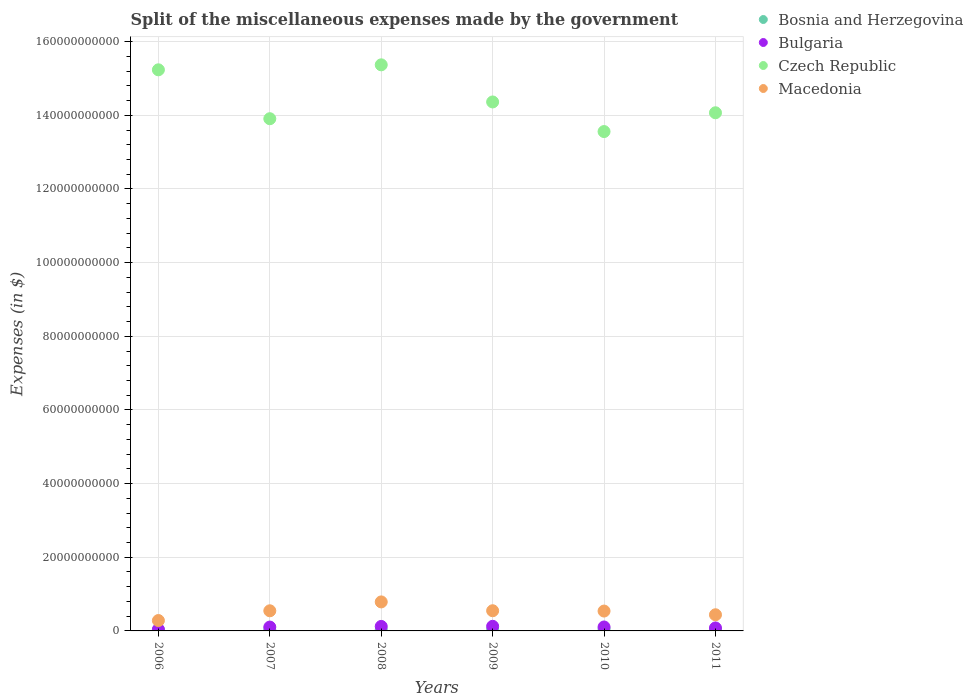How many different coloured dotlines are there?
Keep it short and to the point. 4. Is the number of dotlines equal to the number of legend labels?
Keep it short and to the point. Yes. What is the miscellaneous expenses made by the government in Bulgaria in 2011?
Your answer should be compact. 8.07e+08. Across all years, what is the maximum miscellaneous expenses made by the government in Bulgaria?
Your answer should be compact. 1.25e+09. Across all years, what is the minimum miscellaneous expenses made by the government in Bulgaria?
Make the answer very short. 4.12e+08. In which year was the miscellaneous expenses made by the government in Macedonia maximum?
Make the answer very short. 2008. What is the total miscellaneous expenses made by the government in Macedonia in the graph?
Your answer should be very brief. 3.14e+1. What is the difference between the miscellaneous expenses made by the government in Macedonia in 2008 and that in 2009?
Your answer should be very brief. 2.40e+09. What is the difference between the miscellaneous expenses made by the government in Bulgaria in 2006 and the miscellaneous expenses made by the government in Macedonia in 2008?
Your response must be concise. -7.47e+09. What is the average miscellaneous expenses made by the government in Czech Republic per year?
Provide a succinct answer. 1.44e+11. In the year 2006, what is the difference between the miscellaneous expenses made by the government in Bosnia and Herzegovina and miscellaneous expenses made by the government in Czech Republic?
Your answer should be compact. -1.52e+11. What is the ratio of the miscellaneous expenses made by the government in Bulgaria in 2006 to that in 2008?
Provide a succinct answer. 0.34. Is the difference between the miscellaneous expenses made by the government in Bosnia and Herzegovina in 2007 and 2011 greater than the difference between the miscellaneous expenses made by the government in Czech Republic in 2007 and 2011?
Ensure brevity in your answer.  Yes. What is the difference between the highest and the second highest miscellaneous expenses made by the government in Macedonia?
Make the answer very short. 2.40e+09. What is the difference between the highest and the lowest miscellaneous expenses made by the government in Bosnia and Herzegovina?
Your response must be concise. 2.61e+08. Is it the case that in every year, the sum of the miscellaneous expenses made by the government in Bosnia and Herzegovina and miscellaneous expenses made by the government in Bulgaria  is greater than the sum of miscellaneous expenses made by the government in Macedonia and miscellaneous expenses made by the government in Czech Republic?
Your answer should be compact. No. Is the miscellaneous expenses made by the government in Bosnia and Herzegovina strictly greater than the miscellaneous expenses made by the government in Czech Republic over the years?
Your answer should be compact. No. Is the miscellaneous expenses made by the government in Bulgaria strictly less than the miscellaneous expenses made by the government in Macedonia over the years?
Your response must be concise. Yes. How many dotlines are there?
Ensure brevity in your answer.  4. How many years are there in the graph?
Offer a very short reply. 6. What is the difference between two consecutive major ticks on the Y-axis?
Give a very brief answer. 2.00e+1. Are the values on the major ticks of Y-axis written in scientific E-notation?
Your answer should be very brief. No. Where does the legend appear in the graph?
Keep it short and to the point. Top right. How many legend labels are there?
Offer a terse response. 4. What is the title of the graph?
Offer a terse response. Split of the miscellaneous expenses made by the government. Does "Greece" appear as one of the legend labels in the graph?
Keep it short and to the point. No. What is the label or title of the Y-axis?
Give a very brief answer. Expenses (in $). What is the Expenses (in $) of Bosnia and Herzegovina in 2006?
Offer a terse response. 2.46e+08. What is the Expenses (in $) in Bulgaria in 2006?
Your response must be concise. 4.12e+08. What is the Expenses (in $) in Czech Republic in 2006?
Offer a very short reply. 1.52e+11. What is the Expenses (in $) in Macedonia in 2006?
Give a very brief answer. 2.82e+09. What is the Expenses (in $) in Bosnia and Herzegovina in 2007?
Ensure brevity in your answer.  3.01e+08. What is the Expenses (in $) of Bulgaria in 2007?
Ensure brevity in your answer.  1.05e+09. What is the Expenses (in $) in Czech Republic in 2007?
Make the answer very short. 1.39e+11. What is the Expenses (in $) of Macedonia in 2007?
Make the answer very short. 5.47e+09. What is the Expenses (in $) of Bosnia and Herzegovina in 2008?
Offer a very short reply. 3.19e+08. What is the Expenses (in $) in Bulgaria in 2008?
Your answer should be very brief. 1.22e+09. What is the Expenses (in $) of Czech Republic in 2008?
Make the answer very short. 1.54e+11. What is the Expenses (in $) of Macedonia in 2008?
Give a very brief answer. 7.88e+09. What is the Expenses (in $) in Bosnia and Herzegovina in 2009?
Your answer should be compact. 3.49e+08. What is the Expenses (in $) in Bulgaria in 2009?
Provide a succinct answer. 1.25e+09. What is the Expenses (in $) of Czech Republic in 2009?
Offer a terse response. 1.44e+11. What is the Expenses (in $) of Macedonia in 2009?
Your answer should be compact. 5.48e+09. What is the Expenses (in $) in Bosnia and Herzegovina in 2010?
Your answer should be very brief. 5.07e+08. What is the Expenses (in $) in Bulgaria in 2010?
Make the answer very short. 1.07e+09. What is the Expenses (in $) in Czech Republic in 2010?
Your response must be concise. 1.36e+11. What is the Expenses (in $) of Macedonia in 2010?
Keep it short and to the point. 5.39e+09. What is the Expenses (in $) in Bosnia and Herzegovina in 2011?
Keep it short and to the point. 3.88e+08. What is the Expenses (in $) in Bulgaria in 2011?
Offer a very short reply. 8.07e+08. What is the Expenses (in $) of Czech Republic in 2011?
Provide a succinct answer. 1.41e+11. What is the Expenses (in $) in Macedonia in 2011?
Give a very brief answer. 4.39e+09. Across all years, what is the maximum Expenses (in $) in Bosnia and Herzegovina?
Your response must be concise. 5.07e+08. Across all years, what is the maximum Expenses (in $) of Bulgaria?
Offer a very short reply. 1.25e+09. Across all years, what is the maximum Expenses (in $) in Czech Republic?
Keep it short and to the point. 1.54e+11. Across all years, what is the maximum Expenses (in $) of Macedonia?
Ensure brevity in your answer.  7.88e+09. Across all years, what is the minimum Expenses (in $) in Bosnia and Herzegovina?
Offer a terse response. 2.46e+08. Across all years, what is the minimum Expenses (in $) of Bulgaria?
Give a very brief answer. 4.12e+08. Across all years, what is the minimum Expenses (in $) in Czech Republic?
Give a very brief answer. 1.36e+11. Across all years, what is the minimum Expenses (in $) in Macedonia?
Ensure brevity in your answer.  2.82e+09. What is the total Expenses (in $) of Bosnia and Herzegovina in the graph?
Offer a very short reply. 2.11e+09. What is the total Expenses (in $) of Bulgaria in the graph?
Your response must be concise. 5.81e+09. What is the total Expenses (in $) in Czech Republic in the graph?
Give a very brief answer. 8.65e+11. What is the total Expenses (in $) of Macedonia in the graph?
Keep it short and to the point. 3.14e+1. What is the difference between the Expenses (in $) of Bosnia and Herzegovina in 2006 and that in 2007?
Ensure brevity in your answer.  -5.57e+07. What is the difference between the Expenses (in $) in Bulgaria in 2006 and that in 2007?
Ensure brevity in your answer.  -6.37e+08. What is the difference between the Expenses (in $) of Czech Republic in 2006 and that in 2007?
Your response must be concise. 1.33e+1. What is the difference between the Expenses (in $) of Macedonia in 2006 and that in 2007?
Your response must be concise. -2.65e+09. What is the difference between the Expenses (in $) in Bosnia and Herzegovina in 2006 and that in 2008?
Offer a terse response. -7.28e+07. What is the difference between the Expenses (in $) in Bulgaria in 2006 and that in 2008?
Provide a succinct answer. -8.09e+08. What is the difference between the Expenses (in $) in Czech Republic in 2006 and that in 2008?
Provide a short and direct response. -1.35e+09. What is the difference between the Expenses (in $) of Macedonia in 2006 and that in 2008?
Provide a succinct answer. -5.06e+09. What is the difference between the Expenses (in $) of Bosnia and Herzegovina in 2006 and that in 2009?
Make the answer very short. -1.03e+08. What is the difference between the Expenses (in $) of Bulgaria in 2006 and that in 2009?
Keep it short and to the point. -8.41e+08. What is the difference between the Expenses (in $) of Czech Republic in 2006 and that in 2009?
Give a very brief answer. 8.73e+09. What is the difference between the Expenses (in $) of Macedonia in 2006 and that in 2009?
Give a very brief answer. -2.66e+09. What is the difference between the Expenses (in $) in Bosnia and Herzegovina in 2006 and that in 2010?
Ensure brevity in your answer.  -2.61e+08. What is the difference between the Expenses (in $) of Bulgaria in 2006 and that in 2010?
Your response must be concise. -6.59e+08. What is the difference between the Expenses (in $) in Czech Republic in 2006 and that in 2010?
Offer a terse response. 1.68e+1. What is the difference between the Expenses (in $) of Macedonia in 2006 and that in 2010?
Provide a succinct answer. -2.57e+09. What is the difference between the Expenses (in $) in Bosnia and Herzegovina in 2006 and that in 2011?
Ensure brevity in your answer.  -1.42e+08. What is the difference between the Expenses (in $) of Bulgaria in 2006 and that in 2011?
Your answer should be very brief. -3.96e+08. What is the difference between the Expenses (in $) in Czech Republic in 2006 and that in 2011?
Ensure brevity in your answer.  1.17e+1. What is the difference between the Expenses (in $) in Macedonia in 2006 and that in 2011?
Give a very brief answer. -1.57e+09. What is the difference between the Expenses (in $) in Bosnia and Herzegovina in 2007 and that in 2008?
Your answer should be compact. -1.71e+07. What is the difference between the Expenses (in $) of Bulgaria in 2007 and that in 2008?
Keep it short and to the point. -1.72e+08. What is the difference between the Expenses (in $) in Czech Republic in 2007 and that in 2008?
Your answer should be compact. -1.46e+1. What is the difference between the Expenses (in $) of Macedonia in 2007 and that in 2008?
Your response must be concise. -2.41e+09. What is the difference between the Expenses (in $) of Bosnia and Herzegovina in 2007 and that in 2009?
Provide a short and direct response. -4.74e+07. What is the difference between the Expenses (in $) of Bulgaria in 2007 and that in 2009?
Give a very brief answer. -2.05e+08. What is the difference between the Expenses (in $) of Czech Republic in 2007 and that in 2009?
Keep it short and to the point. -4.55e+09. What is the difference between the Expenses (in $) of Macedonia in 2007 and that in 2009?
Ensure brevity in your answer.  -1.40e+07. What is the difference between the Expenses (in $) in Bosnia and Herzegovina in 2007 and that in 2010?
Offer a terse response. -2.06e+08. What is the difference between the Expenses (in $) in Bulgaria in 2007 and that in 2010?
Your answer should be compact. -2.27e+07. What is the difference between the Expenses (in $) in Czech Republic in 2007 and that in 2010?
Provide a short and direct response. 3.49e+09. What is the difference between the Expenses (in $) in Macedonia in 2007 and that in 2010?
Your answer should be compact. 7.30e+07. What is the difference between the Expenses (in $) in Bosnia and Herzegovina in 2007 and that in 2011?
Your answer should be very brief. -8.66e+07. What is the difference between the Expenses (in $) of Bulgaria in 2007 and that in 2011?
Your response must be concise. 2.41e+08. What is the difference between the Expenses (in $) of Czech Republic in 2007 and that in 2011?
Offer a very short reply. -1.61e+09. What is the difference between the Expenses (in $) in Macedonia in 2007 and that in 2011?
Offer a very short reply. 1.08e+09. What is the difference between the Expenses (in $) of Bosnia and Herzegovina in 2008 and that in 2009?
Keep it short and to the point. -3.03e+07. What is the difference between the Expenses (in $) in Bulgaria in 2008 and that in 2009?
Ensure brevity in your answer.  -3.22e+07. What is the difference between the Expenses (in $) of Czech Republic in 2008 and that in 2009?
Offer a very short reply. 1.01e+1. What is the difference between the Expenses (in $) in Macedonia in 2008 and that in 2009?
Provide a short and direct response. 2.40e+09. What is the difference between the Expenses (in $) in Bosnia and Herzegovina in 2008 and that in 2010?
Keep it short and to the point. -1.89e+08. What is the difference between the Expenses (in $) in Bulgaria in 2008 and that in 2010?
Your answer should be very brief. 1.50e+08. What is the difference between the Expenses (in $) of Czech Republic in 2008 and that in 2010?
Make the answer very short. 1.81e+1. What is the difference between the Expenses (in $) in Macedonia in 2008 and that in 2010?
Give a very brief answer. 2.48e+09. What is the difference between the Expenses (in $) of Bosnia and Herzegovina in 2008 and that in 2011?
Make the answer very short. -6.95e+07. What is the difference between the Expenses (in $) of Bulgaria in 2008 and that in 2011?
Your response must be concise. 4.13e+08. What is the difference between the Expenses (in $) in Czech Republic in 2008 and that in 2011?
Your response must be concise. 1.30e+1. What is the difference between the Expenses (in $) in Macedonia in 2008 and that in 2011?
Provide a succinct answer. 3.49e+09. What is the difference between the Expenses (in $) of Bosnia and Herzegovina in 2009 and that in 2010?
Offer a terse response. -1.58e+08. What is the difference between the Expenses (in $) in Bulgaria in 2009 and that in 2010?
Make the answer very short. 1.82e+08. What is the difference between the Expenses (in $) of Czech Republic in 2009 and that in 2010?
Give a very brief answer. 8.04e+09. What is the difference between the Expenses (in $) of Macedonia in 2009 and that in 2010?
Ensure brevity in your answer.  8.70e+07. What is the difference between the Expenses (in $) of Bosnia and Herzegovina in 2009 and that in 2011?
Provide a succinct answer. -3.92e+07. What is the difference between the Expenses (in $) of Bulgaria in 2009 and that in 2011?
Your answer should be compact. 4.46e+08. What is the difference between the Expenses (in $) in Czech Republic in 2009 and that in 2011?
Provide a short and direct response. 2.94e+09. What is the difference between the Expenses (in $) in Macedonia in 2009 and that in 2011?
Ensure brevity in your answer.  1.09e+09. What is the difference between the Expenses (in $) in Bosnia and Herzegovina in 2010 and that in 2011?
Give a very brief answer. 1.19e+08. What is the difference between the Expenses (in $) of Bulgaria in 2010 and that in 2011?
Make the answer very short. 2.64e+08. What is the difference between the Expenses (in $) of Czech Republic in 2010 and that in 2011?
Provide a short and direct response. -5.10e+09. What is the difference between the Expenses (in $) in Macedonia in 2010 and that in 2011?
Offer a terse response. 1.01e+09. What is the difference between the Expenses (in $) of Bosnia and Herzegovina in 2006 and the Expenses (in $) of Bulgaria in 2007?
Provide a short and direct response. -8.03e+08. What is the difference between the Expenses (in $) of Bosnia and Herzegovina in 2006 and the Expenses (in $) of Czech Republic in 2007?
Your response must be concise. -1.39e+11. What is the difference between the Expenses (in $) in Bosnia and Herzegovina in 2006 and the Expenses (in $) in Macedonia in 2007?
Keep it short and to the point. -5.22e+09. What is the difference between the Expenses (in $) of Bulgaria in 2006 and the Expenses (in $) of Czech Republic in 2007?
Give a very brief answer. -1.39e+11. What is the difference between the Expenses (in $) of Bulgaria in 2006 and the Expenses (in $) of Macedonia in 2007?
Offer a terse response. -5.05e+09. What is the difference between the Expenses (in $) of Czech Republic in 2006 and the Expenses (in $) of Macedonia in 2007?
Offer a very short reply. 1.47e+11. What is the difference between the Expenses (in $) in Bosnia and Herzegovina in 2006 and the Expenses (in $) in Bulgaria in 2008?
Give a very brief answer. -9.75e+08. What is the difference between the Expenses (in $) in Bosnia and Herzegovina in 2006 and the Expenses (in $) in Czech Republic in 2008?
Give a very brief answer. -1.53e+11. What is the difference between the Expenses (in $) in Bosnia and Herzegovina in 2006 and the Expenses (in $) in Macedonia in 2008?
Your response must be concise. -7.63e+09. What is the difference between the Expenses (in $) of Bulgaria in 2006 and the Expenses (in $) of Czech Republic in 2008?
Provide a succinct answer. -1.53e+11. What is the difference between the Expenses (in $) in Bulgaria in 2006 and the Expenses (in $) in Macedonia in 2008?
Keep it short and to the point. -7.47e+09. What is the difference between the Expenses (in $) of Czech Republic in 2006 and the Expenses (in $) of Macedonia in 2008?
Offer a terse response. 1.44e+11. What is the difference between the Expenses (in $) in Bosnia and Herzegovina in 2006 and the Expenses (in $) in Bulgaria in 2009?
Offer a very short reply. -1.01e+09. What is the difference between the Expenses (in $) of Bosnia and Herzegovina in 2006 and the Expenses (in $) of Czech Republic in 2009?
Your answer should be compact. -1.43e+11. What is the difference between the Expenses (in $) of Bosnia and Herzegovina in 2006 and the Expenses (in $) of Macedonia in 2009?
Give a very brief answer. -5.23e+09. What is the difference between the Expenses (in $) of Bulgaria in 2006 and the Expenses (in $) of Czech Republic in 2009?
Offer a terse response. -1.43e+11. What is the difference between the Expenses (in $) of Bulgaria in 2006 and the Expenses (in $) of Macedonia in 2009?
Provide a succinct answer. -5.07e+09. What is the difference between the Expenses (in $) in Czech Republic in 2006 and the Expenses (in $) in Macedonia in 2009?
Ensure brevity in your answer.  1.47e+11. What is the difference between the Expenses (in $) in Bosnia and Herzegovina in 2006 and the Expenses (in $) in Bulgaria in 2010?
Give a very brief answer. -8.25e+08. What is the difference between the Expenses (in $) in Bosnia and Herzegovina in 2006 and the Expenses (in $) in Czech Republic in 2010?
Your response must be concise. -1.35e+11. What is the difference between the Expenses (in $) in Bosnia and Herzegovina in 2006 and the Expenses (in $) in Macedonia in 2010?
Ensure brevity in your answer.  -5.15e+09. What is the difference between the Expenses (in $) of Bulgaria in 2006 and the Expenses (in $) of Czech Republic in 2010?
Your answer should be compact. -1.35e+11. What is the difference between the Expenses (in $) of Bulgaria in 2006 and the Expenses (in $) of Macedonia in 2010?
Provide a succinct answer. -4.98e+09. What is the difference between the Expenses (in $) in Czech Republic in 2006 and the Expenses (in $) in Macedonia in 2010?
Your answer should be very brief. 1.47e+11. What is the difference between the Expenses (in $) of Bosnia and Herzegovina in 2006 and the Expenses (in $) of Bulgaria in 2011?
Your response must be concise. -5.62e+08. What is the difference between the Expenses (in $) in Bosnia and Herzegovina in 2006 and the Expenses (in $) in Czech Republic in 2011?
Your answer should be compact. -1.40e+11. What is the difference between the Expenses (in $) in Bosnia and Herzegovina in 2006 and the Expenses (in $) in Macedonia in 2011?
Your response must be concise. -4.14e+09. What is the difference between the Expenses (in $) in Bulgaria in 2006 and the Expenses (in $) in Czech Republic in 2011?
Provide a short and direct response. -1.40e+11. What is the difference between the Expenses (in $) in Bulgaria in 2006 and the Expenses (in $) in Macedonia in 2011?
Offer a terse response. -3.98e+09. What is the difference between the Expenses (in $) of Czech Republic in 2006 and the Expenses (in $) of Macedonia in 2011?
Keep it short and to the point. 1.48e+11. What is the difference between the Expenses (in $) in Bosnia and Herzegovina in 2007 and the Expenses (in $) in Bulgaria in 2008?
Offer a very short reply. -9.19e+08. What is the difference between the Expenses (in $) in Bosnia and Herzegovina in 2007 and the Expenses (in $) in Czech Republic in 2008?
Offer a very short reply. -1.53e+11. What is the difference between the Expenses (in $) of Bosnia and Herzegovina in 2007 and the Expenses (in $) of Macedonia in 2008?
Provide a succinct answer. -7.58e+09. What is the difference between the Expenses (in $) of Bulgaria in 2007 and the Expenses (in $) of Czech Republic in 2008?
Give a very brief answer. -1.53e+11. What is the difference between the Expenses (in $) in Bulgaria in 2007 and the Expenses (in $) in Macedonia in 2008?
Provide a succinct answer. -6.83e+09. What is the difference between the Expenses (in $) in Czech Republic in 2007 and the Expenses (in $) in Macedonia in 2008?
Your answer should be very brief. 1.31e+11. What is the difference between the Expenses (in $) in Bosnia and Herzegovina in 2007 and the Expenses (in $) in Bulgaria in 2009?
Your answer should be compact. -9.52e+08. What is the difference between the Expenses (in $) in Bosnia and Herzegovina in 2007 and the Expenses (in $) in Czech Republic in 2009?
Your response must be concise. -1.43e+11. What is the difference between the Expenses (in $) in Bosnia and Herzegovina in 2007 and the Expenses (in $) in Macedonia in 2009?
Make the answer very short. -5.18e+09. What is the difference between the Expenses (in $) in Bulgaria in 2007 and the Expenses (in $) in Czech Republic in 2009?
Make the answer very short. -1.43e+11. What is the difference between the Expenses (in $) in Bulgaria in 2007 and the Expenses (in $) in Macedonia in 2009?
Offer a terse response. -4.43e+09. What is the difference between the Expenses (in $) of Czech Republic in 2007 and the Expenses (in $) of Macedonia in 2009?
Your response must be concise. 1.34e+11. What is the difference between the Expenses (in $) in Bosnia and Herzegovina in 2007 and the Expenses (in $) in Bulgaria in 2010?
Ensure brevity in your answer.  -7.70e+08. What is the difference between the Expenses (in $) of Bosnia and Herzegovina in 2007 and the Expenses (in $) of Czech Republic in 2010?
Provide a short and direct response. -1.35e+11. What is the difference between the Expenses (in $) in Bosnia and Herzegovina in 2007 and the Expenses (in $) in Macedonia in 2010?
Your answer should be very brief. -5.09e+09. What is the difference between the Expenses (in $) in Bulgaria in 2007 and the Expenses (in $) in Czech Republic in 2010?
Provide a succinct answer. -1.35e+11. What is the difference between the Expenses (in $) in Bulgaria in 2007 and the Expenses (in $) in Macedonia in 2010?
Ensure brevity in your answer.  -4.34e+09. What is the difference between the Expenses (in $) in Czech Republic in 2007 and the Expenses (in $) in Macedonia in 2010?
Your answer should be very brief. 1.34e+11. What is the difference between the Expenses (in $) in Bosnia and Herzegovina in 2007 and the Expenses (in $) in Bulgaria in 2011?
Offer a terse response. -5.06e+08. What is the difference between the Expenses (in $) in Bosnia and Herzegovina in 2007 and the Expenses (in $) in Czech Republic in 2011?
Your response must be concise. -1.40e+11. What is the difference between the Expenses (in $) in Bosnia and Herzegovina in 2007 and the Expenses (in $) in Macedonia in 2011?
Ensure brevity in your answer.  -4.09e+09. What is the difference between the Expenses (in $) of Bulgaria in 2007 and the Expenses (in $) of Czech Republic in 2011?
Provide a short and direct response. -1.40e+11. What is the difference between the Expenses (in $) of Bulgaria in 2007 and the Expenses (in $) of Macedonia in 2011?
Your response must be concise. -3.34e+09. What is the difference between the Expenses (in $) of Czech Republic in 2007 and the Expenses (in $) of Macedonia in 2011?
Provide a short and direct response. 1.35e+11. What is the difference between the Expenses (in $) in Bosnia and Herzegovina in 2008 and the Expenses (in $) in Bulgaria in 2009?
Provide a short and direct response. -9.34e+08. What is the difference between the Expenses (in $) in Bosnia and Herzegovina in 2008 and the Expenses (in $) in Czech Republic in 2009?
Your response must be concise. -1.43e+11. What is the difference between the Expenses (in $) in Bosnia and Herzegovina in 2008 and the Expenses (in $) in Macedonia in 2009?
Provide a succinct answer. -5.16e+09. What is the difference between the Expenses (in $) of Bulgaria in 2008 and the Expenses (in $) of Czech Republic in 2009?
Provide a succinct answer. -1.42e+11. What is the difference between the Expenses (in $) of Bulgaria in 2008 and the Expenses (in $) of Macedonia in 2009?
Your answer should be compact. -4.26e+09. What is the difference between the Expenses (in $) in Czech Republic in 2008 and the Expenses (in $) in Macedonia in 2009?
Your response must be concise. 1.48e+11. What is the difference between the Expenses (in $) in Bosnia and Herzegovina in 2008 and the Expenses (in $) in Bulgaria in 2010?
Ensure brevity in your answer.  -7.53e+08. What is the difference between the Expenses (in $) in Bosnia and Herzegovina in 2008 and the Expenses (in $) in Czech Republic in 2010?
Offer a very short reply. -1.35e+11. What is the difference between the Expenses (in $) of Bosnia and Herzegovina in 2008 and the Expenses (in $) of Macedonia in 2010?
Make the answer very short. -5.07e+09. What is the difference between the Expenses (in $) in Bulgaria in 2008 and the Expenses (in $) in Czech Republic in 2010?
Provide a short and direct response. -1.34e+11. What is the difference between the Expenses (in $) in Bulgaria in 2008 and the Expenses (in $) in Macedonia in 2010?
Ensure brevity in your answer.  -4.17e+09. What is the difference between the Expenses (in $) in Czech Republic in 2008 and the Expenses (in $) in Macedonia in 2010?
Your answer should be very brief. 1.48e+11. What is the difference between the Expenses (in $) of Bosnia and Herzegovina in 2008 and the Expenses (in $) of Bulgaria in 2011?
Provide a short and direct response. -4.89e+08. What is the difference between the Expenses (in $) of Bosnia and Herzegovina in 2008 and the Expenses (in $) of Czech Republic in 2011?
Offer a very short reply. -1.40e+11. What is the difference between the Expenses (in $) of Bosnia and Herzegovina in 2008 and the Expenses (in $) of Macedonia in 2011?
Provide a succinct answer. -4.07e+09. What is the difference between the Expenses (in $) of Bulgaria in 2008 and the Expenses (in $) of Czech Republic in 2011?
Your answer should be compact. -1.39e+11. What is the difference between the Expenses (in $) of Bulgaria in 2008 and the Expenses (in $) of Macedonia in 2011?
Your answer should be very brief. -3.17e+09. What is the difference between the Expenses (in $) in Czech Republic in 2008 and the Expenses (in $) in Macedonia in 2011?
Your answer should be compact. 1.49e+11. What is the difference between the Expenses (in $) in Bosnia and Herzegovina in 2009 and the Expenses (in $) in Bulgaria in 2010?
Ensure brevity in your answer.  -7.22e+08. What is the difference between the Expenses (in $) in Bosnia and Herzegovina in 2009 and the Expenses (in $) in Czech Republic in 2010?
Your answer should be compact. -1.35e+11. What is the difference between the Expenses (in $) in Bosnia and Herzegovina in 2009 and the Expenses (in $) in Macedonia in 2010?
Keep it short and to the point. -5.04e+09. What is the difference between the Expenses (in $) in Bulgaria in 2009 and the Expenses (in $) in Czech Republic in 2010?
Make the answer very short. -1.34e+11. What is the difference between the Expenses (in $) in Bulgaria in 2009 and the Expenses (in $) in Macedonia in 2010?
Offer a very short reply. -4.14e+09. What is the difference between the Expenses (in $) of Czech Republic in 2009 and the Expenses (in $) of Macedonia in 2010?
Give a very brief answer. 1.38e+11. What is the difference between the Expenses (in $) in Bosnia and Herzegovina in 2009 and the Expenses (in $) in Bulgaria in 2011?
Your response must be concise. -4.59e+08. What is the difference between the Expenses (in $) of Bosnia and Herzegovina in 2009 and the Expenses (in $) of Czech Republic in 2011?
Give a very brief answer. -1.40e+11. What is the difference between the Expenses (in $) of Bosnia and Herzegovina in 2009 and the Expenses (in $) of Macedonia in 2011?
Offer a terse response. -4.04e+09. What is the difference between the Expenses (in $) of Bulgaria in 2009 and the Expenses (in $) of Czech Republic in 2011?
Ensure brevity in your answer.  -1.39e+11. What is the difference between the Expenses (in $) of Bulgaria in 2009 and the Expenses (in $) of Macedonia in 2011?
Give a very brief answer. -3.13e+09. What is the difference between the Expenses (in $) in Czech Republic in 2009 and the Expenses (in $) in Macedonia in 2011?
Your answer should be compact. 1.39e+11. What is the difference between the Expenses (in $) in Bosnia and Herzegovina in 2010 and the Expenses (in $) in Bulgaria in 2011?
Your answer should be compact. -3.00e+08. What is the difference between the Expenses (in $) of Bosnia and Herzegovina in 2010 and the Expenses (in $) of Czech Republic in 2011?
Keep it short and to the point. -1.40e+11. What is the difference between the Expenses (in $) of Bosnia and Herzegovina in 2010 and the Expenses (in $) of Macedonia in 2011?
Offer a very short reply. -3.88e+09. What is the difference between the Expenses (in $) of Bulgaria in 2010 and the Expenses (in $) of Czech Republic in 2011?
Your response must be concise. -1.40e+11. What is the difference between the Expenses (in $) in Bulgaria in 2010 and the Expenses (in $) in Macedonia in 2011?
Provide a short and direct response. -3.32e+09. What is the difference between the Expenses (in $) of Czech Republic in 2010 and the Expenses (in $) of Macedonia in 2011?
Ensure brevity in your answer.  1.31e+11. What is the average Expenses (in $) in Bosnia and Herzegovina per year?
Keep it short and to the point. 3.52e+08. What is the average Expenses (in $) of Bulgaria per year?
Provide a succinct answer. 9.69e+08. What is the average Expenses (in $) of Czech Republic per year?
Keep it short and to the point. 1.44e+11. What is the average Expenses (in $) of Macedonia per year?
Provide a short and direct response. 5.24e+09. In the year 2006, what is the difference between the Expenses (in $) of Bosnia and Herzegovina and Expenses (in $) of Bulgaria?
Your answer should be very brief. -1.66e+08. In the year 2006, what is the difference between the Expenses (in $) in Bosnia and Herzegovina and Expenses (in $) in Czech Republic?
Your answer should be very brief. -1.52e+11. In the year 2006, what is the difference between the Expenses (in $) in Bosnia and Herzegovina and Expenses (in $) in Macedonia?
Your response must be concise. -2.57e+09. In the year 2006, what is the difference between the Expenses (in $) of Bulgaria and Expenses (in $) of Czech Republic?
Your response must be concise. -1.52e+11. In the year 2006, what is the difference between the Expenses (in $) of Bulgaria and Expenses (in $) of Macedonia?
Make the answer very short. -2.41e+09. In the year 2006, what is the difference between the Expenses (in $) in Czech Republic and Expenses (in $) in Macedonia?
Your answer should be very brief. 1.50e+11. In the year 2007, what is the difference between the Expenses (in $) of Bosnia and Herzegovina and Expenses (in $) of Bulgaria?
Ensure brevity in your answer.  -7.47e+08. In the year 2007, what is the difference between the Expenses (in $) of Bosnia and Herzegovina and Expenses (in $) of Czech Republic?
Your response must be concise. -1.39e+11. In the year 2007, what is the difference between the Expenses (in $) of Bosnia and Herzegovina and Expenses (in $) of Macedonia?
Your response must be concise. -5.16e+09. In the year 2007, what is the difference between the Expenses (in $) in Bulgaria and Expenses (in $) in Czech Republic?
Keep it short and to the point. -1.38e+11. In the year 2007, what is the difference between the Expenses (in $) in Bulgaria and Expenses (in $) in Macedonia?
Your answer should be very brief. -4.42e+09. In the year 2007, what is the difference between the Expenses (in $) in Czech Republic and Expenses (in $) in Macedonia?
Make the answer very short. 1.34e+11. In the year 2008, what is the difference between the Expenses (in $) of Bosnia and Herzegovina and Expenses (in $) of Bulgaria?
Provide a short and direct response. -9.02e+08. In the year 2008, what is the difference between the Expenses (in $) in Bosnia and Herzegovina and Expenses (in $) in Czech Republic?
Make the answer very short. -1.53e+11. In the year 2008, what is the difference between the Expenses (in $) of Bosnia and Herzegovina and Expenses (in $) of Macedonia?
Your answer should be very brief. -7.56e+09. In the year 2008, what is the difference between the Expenses (in $) of Bulgaria and Expenses (in $) of Czech Republic?
Your answer should be very brief. -1.52e+11. In the year 2008, what is the difference between the Expenses (in $) in Bulgaria and Expenses (in $) in Macedonia?
Your answer should be very brief. -6.66e+09. In the year 2008, what is the difference between the Expenses (in $) of Czech Republic and Expenses (in $) of Macedonia?
Offer a terse response. 1.46e+11. In the year 2009, what is the difference between the Expenses (in $) of Bosnia and Herzegovina and Expenses (in $) of Bulgaria?
Your answer should be compact. -9.04e+08. In the year 2009, what is the difference between the Expenses (in $) of Bosnia and Herzegovina and Expenses (in $) of Czech Republic?
Your response must be concise. -1.43e+11. In the year 2009, what is the difference between the Expenses (in $) in Bosnia and Herzegovina and Expenses (in $) in Macedonia?
Your response must be concise. -5.13e+09. In the year 2009, what is the difference between the Expenses (in $) of Bulgaria and Expenses (in $) of Czech Republic?
Ensure brevity in your answer.  -1.42e+11. In the year 2009, what is the difference between the Expenses (in $) in Bulgaria and Expenses (in $) in Macedonia?
Make the answer very short. -4.23e+09. In the year 2009, what is the difference between the Expenses (in $) of Czech Republic and Expenses (in $) of Macedonia?
Offer a very short reply. 1.38e+11. In the year 2010, what is the difference between the Expenses (in $) of Bosnia and Herzegovina and Expenses (in $) of Bulgaria?
Offer a very short reply. -5.64e+08. In the year 2010, what is the difference between the Expenses (in $) in Bosnia and Herzegovina and Expenses (in $) in Czech Republic?
Give a very brief answer. -1.35e+11. In the year 2010, what is the difference between the Expenses (in $) in Bosnia and Herzegovina and Expenses (in $) in Macedonia?
Provide a short and direct response. -4.89e+09. In the year 2010, what is the difference between the Expenses (in $) in Bulgaria and Expenses (in $) in Czech Republic?
Your response must be concise. -1.35e+11. In the year 2010, what is the difference between the Expenses (in $) in Bulgaria and Expenses (in $) in Macedonia?
Your answer should be compact. -4.32e+09. In the year 2010, what is the difference between the Expenses (in $) in Czech Republic and Expenses (in $) in Macedonia?
Offer a terse response. 1.30e+11. In the year 2011, what is the difference between the Expenses (in $) in Bosnia and Herzegovina and Expenses (in $) in Bulgaria?
Make the answer very short. -4.19e+08. In the year 2011, what is the difference between the Expenses (in $) of Bosnia and Herzegovina and Expenses (in $) of Czech Republic?
Your answer should be very brief. -1.40e+11. In the year 2011, what is the difference between the Expenses (in $) in Bosnia and Herzegovina and Expenses (in $) in Macedonia?
Provide a short and direct response. -4.00e+09. In the year 2011, what is the difference between the Expenses (in $) of Bulgaria and Expenses (in $) of Czech Republic?
Your answer should be very brief. -1.40e+11. In the year 2011, what is the difference between the Expenses (in $) of Bulgaria and Expenses (in $) of Macedonia?
Your answer should be very brief. -3.58e+09. In the year 2011, what is the difference between the Expenses (in $) in Czech Republic and Expenses (in $) in Macedonia?
Your answer should be very brief. 1.36e+11. What is the ratio of the Expenses (in $) in Bosnia and Herzegovina in 2006 to that in 2007?
Offer a very short reply. 0.82. What is the ratio of the Expenses (in $) of Bulgaria in 2006 to that in 2007?
Keep it short and to the point. 0.39. What is the ratio of the Expenses (in $) in Czech Republic in 2006 to that in 2007?
Give a very brief answer. 1.1. What is the ratio of the Expenses (in $) in Macedonia in 2006 to that in 2007?
Your answer should be compact. 0.52. What is the ratio of the Expenses (in $) in Bosnia and Herzegovina in 2006 to that in 2008?
Provide a short and direct response. 0.77. What is the ratio of the Expenses (in $) of Bulgaria in 2006 to that in 2008?
Your answer should be very brief. 0.34. What is the ratio of the Expenses (in $) in Macedonia in 2006 to that in 2008?
Provide a succinct answer. 0.36. What is the ratio of the Expenses (in $) of Bosnia and Herzegovina in 2006 to that in 2009?
Provide a succinct answer. 0.7. What is the ratio of the Expenses (in $) of Bulgaria in 2006 to that in 2009?
Your answer should be very brief. 0.33. What is the ratio of the Expenses (in $) in Czech Republic in 2006 to that in 2009?
Provide a short and direct response. 1.06. What is the ratio of the Expenses (in $) in Macedonia in 2006 to that in 2009?
Provide a succinct answer. 0.51. What is the ratio of the Expenses (in $) in Bosnia and Herzegovina in 2006 to that in 2010?
Offer a very short reply. 0.48. What is the ratio of the Expenses (in $) in Bulgaria in 2006 to that in 2010?
Offer a very short reply. 0.38. What is the ratio of the Expenses (in $) of Czech Republic in 2006 to that in 2010?
Your answer should be very brief. 1.12. What is the ratio of the Expenses (in $) in Macedonia in 2006 to that in 2010?
Give a very brief answer. 0.52. What is the ratio of the Expenses (in $) in Bosnia and Herzegovina in 2006 to that in 2011?
Provide a succinct answer. 0.63. What is the ratio of the Expenses (in $) of Bulgaria in 2006 to that in 2011?
Provide a succinct answer. 0.51. What is the ratio of the Expenses (in $) in Czech Republic in 2006 to that in 2011?
Give a very brief answer. 1.08. What is the ratio of the Expenses (in $) in Macedonia in 2006 to that in 2011?
Give a very brief answer. 0.64. What is the ratio of the Expenses (in $) in Bosnia and Herzegovina in 2007 to that in 2008?
Give a very brief answer. 0.95. What is the ratio of the Expenses (in $) of Bulgaria in 2007 to that in 2008?
Your answer should be very brief. 0.86. What is the ratio of the Expenses (in $) in Czech Republic in 2007 to that in 2008?
Offer a very short reply. 0.9. What is the ratio of the Expenses (in $) of Macedonia in 2007 to that in 2008?
Make the answer very short. 0.69. What is the ratio of the Expenses (in $) in Bosnia and Herzegovina in 2007 to that in 2009?
Make the answer very short. 0.86. What is the ratio of the Expenses (in $) of Bulgaria in 2007 to that in 2009?
Your answer should be compact. 0.84. What is the ratio of the Expenses (in $) in Czech Republic in 2007 to that in 2009?
Offer a very short reply. 0.97. What is the ratio of the Expenses (in $) in Macedonia in 2007 to that in 2009?
Offer a terse response. 1. What is the ratio of the Expenses (in $) of Bosnia and Herzegovina in 2007 to that in 2010?
Provide a succinct answer. 0.59. What is the ratio of the Expenses (in $) in Bulgaria in 2007 to that in 2010?
Offer a terse response. 0.98. What is the ratio of the Expenses (in $) of Czech Republic in 2007 to that in 2010?
Offer a terse response. 1.03. What is the ratio of the Expenses (in $) in Macedonia in 2007 to that in 2010?
Provide a succinct answer. 1.01. What is the ratio of the Expenses (in $) of Bosnia and Herzegovina in 2007 to that in 2011?
Make the answer very short. 0.78. What is the ratio of the Expenses (in $) of Bulgaria in 2007 to that in 2011?
Provide a succinct answer. 1.3. What is the ratio of the Expenses (in $) in Czech Republic in 2007 to that in 2011?
Provide a short and direct response. 0.99. What is the ratio of the Expenses (in $) of Macedonia in 2007 to that in 2011?
Give a very brief answer. 1.25. What is the ratio of the Expenses (in $) in Bosnia and Herzegovina in 2008 to that in 2009?
Your answer should be compact. 0.91. What is the ratio of the Expenses (in $) of Bulgaria in 2008 to that in 2009?
Your answer should be very brief. 0.97. What is the ratio of the Expenses (in $) of Czech Republic in 2008 to that in 2009?
Provide a short and direct response. 1.07. What is the ratio of the Expenses (in $) of Macedonia in 2008 to that in 2009?
Ensure brevity in your answer.  1.44. What is the ratio of the Expenses (in $) of Bosnia and Herzegovina in 2008 to that in 2010?
Your answer should be compact. 0.63. What is the ratio of the Expenses (in $) of Bulgaria in 2008 to that in 2010?
Provide a succinct answer. 1.14. What is the ratio of the Expenses (in $) of Czech Republic in 2008 to that in 2010?
Offer a very short reply. 1.13. What is the ratio of the Expenses (in $) in Macedonia in 2008 to that in 2010?
Your answer should be very brief. 1.46. What is the ratio of the Expenses (in $) in Bosnia and Herzegovina in 2008 to that in 2011?
Offer a terse response. 0.82. What is the ratio of the Expenses (in $) in Bulgaria in 2008 to that in 2011?
Offer a terse response. 1.51. What is the ratio of the Expenses (in $) of Czech Republic in 2008 to that in 2011?
Your answer should be very brief. 1.09. What is the ratio of the Expenses (in $) of Macedonia in 2008 to that in 2011?
Provide a short and direct response. 1.8. What is the ratio of the Expenses (in $) in Bosnia and Herzegovina in 2009 to that in 2010?
Provide a succinct answer. 0.69. What is the ratio of the Expenses (in $) in Bulgaria in 2009 to that in 2010?
Give a very brief answer. 1.17. What is the ratio of the Expenses (in $) of Czech Republic in 2009 to that in 2010?
Your answer should be very brief. 1.06. What is the ratio of the Expenses (in $) in Macedonia in 2009 to that in 2010?
Keep it short and to the point. 1.02. What is the ratio of the Expenses (in $) in Bosnia and Herzegovina in 2009 to that in 2011?
Provide a short and direct response. 0.9. What is the ratio of the Expenses (in $) in Bulgaria in 2009 to that in 2011?
Your response must be concise. 1.55. What is the ratio of the Expenses (in $) of Czech Republic in 2009 to that in 2011?
Make the answer very short. 1.02. What is the ratio of the Expenses (in $) of Macedonia in 2009 to that in 2011?
Ensure brevity in your answer.  1.25. What is the ratio of the Expenses (in $) of Bosnia and Herzegovina in 2010 to that in 2011?
Your answer should be very brief. 1.31. What is the ratio of the Expenses (in $) of Bulgaria in 2010 to that in 2011?
Offer a terse response. 1.33. What is the ratio of the Expenses (in $) in Czech Republic in 2010 to that in 2011?
Your response must be concise. 0.96. What is the ratio of the Expenses (in $) of Macedonia in 2010 to that in 2011?
Provide a short and direct response. 1.23. What is the difference between the highest and the second highest Expenses (in $) in Bosnia and Herzegovina?
Offer a terse response. 1.19e+08. What is the difference between the highest and the second highest Expenses (in $) in Bulgaria?
Give a very brief answer. 3.22e+07. What is the difference between the highest and the second highest Expenses (in $) in Czech Republic?
Your response must be concise. 1.35e+09. What is the difference between the highest and the second highest Expenses (in $) in Macedonia?
Your response must be concise. 2.40e+09. What is the difference between the highest and the lowest Expenses (in $) in Bosnia and Herzegovina?
Ensure brevity in your answer.  2.61e+08. What is the difference between the highest and the lowest Expenses (in $) in Bulgaria?
Offer a very short reply. 8.41e+08. What is the difference between the highest and the lowest Expenses (in $) in Czech Republic?
Offer a terse response. 1.81e+1. What is the difference between the highest and the lowest Expenses (in $) in Macedonia?
Make the answer very short. 5.06e+09. 